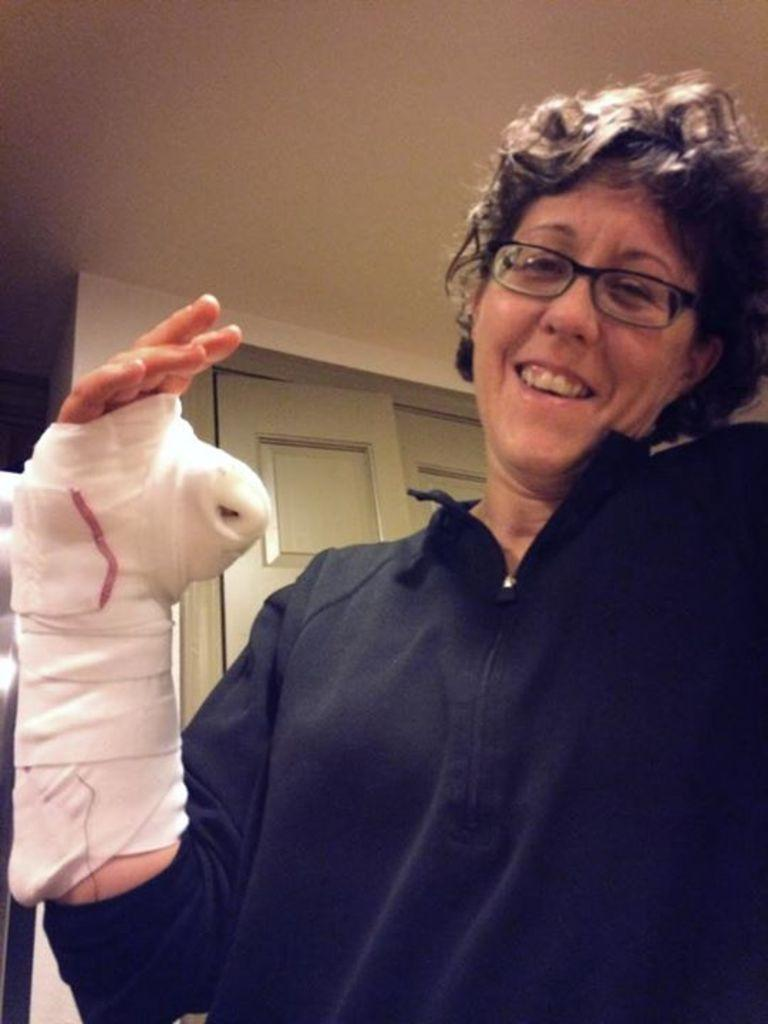Who is the main subject in the image? There is a lady in the image. Where is the lady located in the image? The lady is on the right side of the image. What can be seen behind the lady? There is a door behind the lady. What type of rifle is the lady holding in the image? There is no rifle present in the image; the lady is not holding any object. 